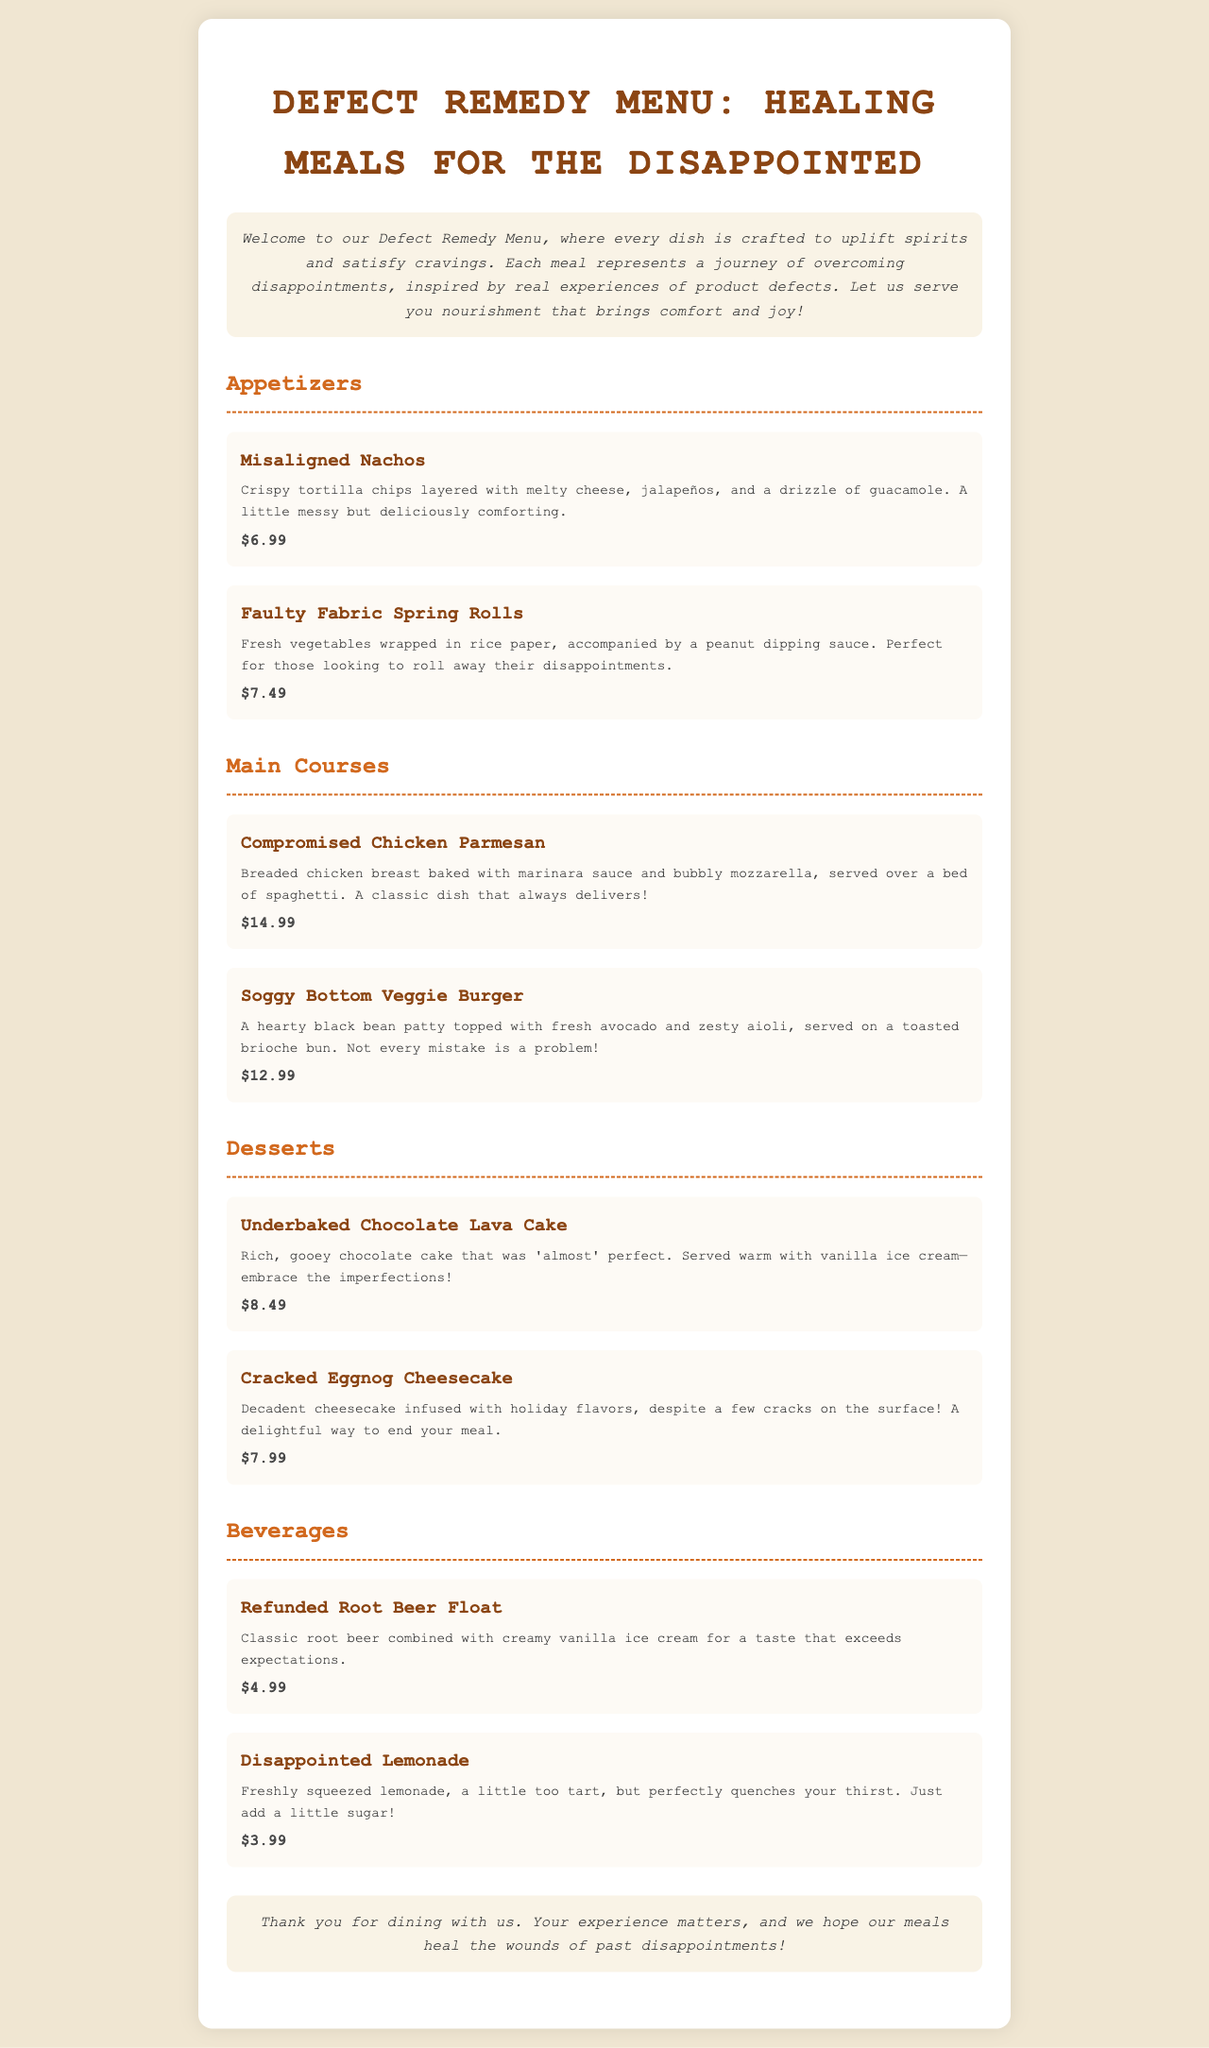What are the appetizers listed on the menu? The appetizers listed in the menu are Misaligned Nachos and Faulty Fabric Spring Rolls.
Answer: Misaligned Nachos, Faulty Fabric Spring Rolls How much does the Underbaked Chocolate Lava Cake cost? The menu states the price of the Underbaked Chocolate Lava Cake is $8.49.
Answer: $8.49 What are the main ingredients of the Soggy Bottom Veggie Burger? The Soggy Bottom Veggie Burger consists of a black bean patty, fresh avocado, and zesty aioli.
Answer: Black bean patty, avocado, aioli Which beverage has a price of $4.99? The Refunded Root Beer Float is the beverage that costs $4.99.
Answer: Refunded Root Beer Float How many desserts are offered on the menu? The menu provides two desserts: Underbaked Chocolate Lava Cake and Cracked Eggnog Cheesecake.
Answer: Two What is the theme of the Defect Remedy Menu? The theme revolves around healing meals crafted to uplift spirits and satisfy cravings, inspired by product defects.
Answer: Healing meals for the disappointed Which main course is described as "a classic dish that always delivers"? The Compromised Chicken Parmesan is described this way on the menu.
Answer: Compromised Chicken Parmesan What type of dish is included in the Beverages section? The Beverages section includes drinks, specifically Refunded Root Beer Float and Disappointed Lemonade.
Answer: Drinks 